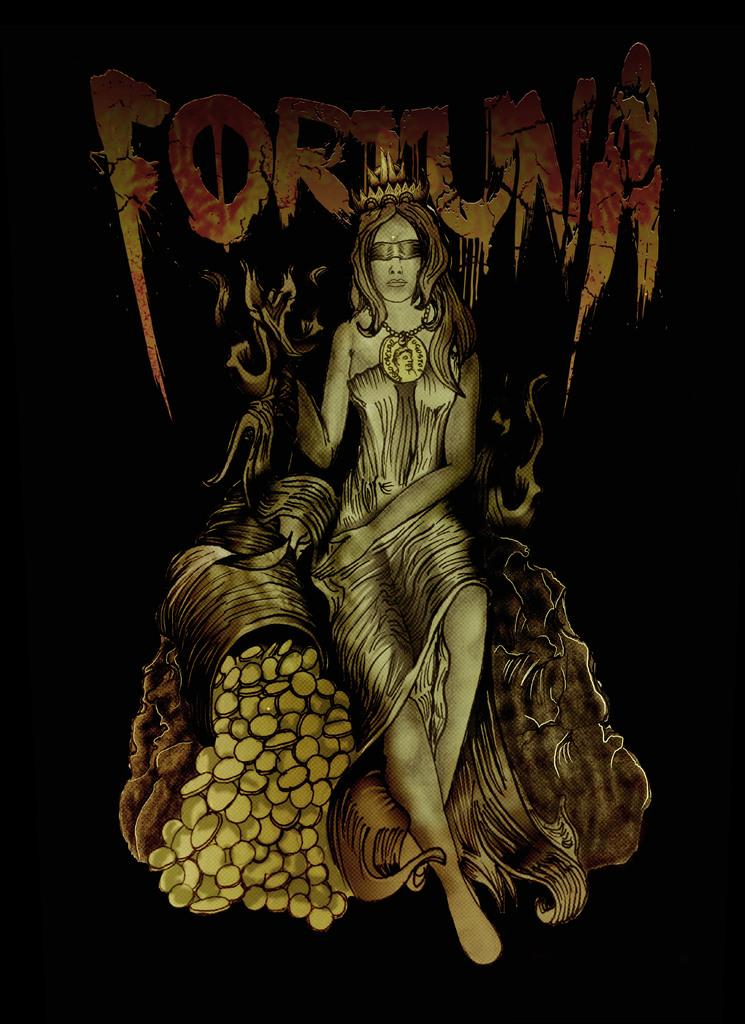What type of image is being described? The image is an illustration. Who is depicted in the illustration? There is a woman in the image. What is the woman doing in the illustration? The woman is sitting. What accessory is the woman wearing in the illustration? The woman is wearing a crown. Are there any words or letters in the illustration? Yes, there is text written on the illustration. What can be observed about the background of the image? The background of the image is dark. What type of building is on fire in the image? There is no building or fire present in the image; it is an illustration of a woman sitting with a crown and text. How does the woman's behavior change throughout the image? The image is a static illustration, so the woman's behavior does not change throughout the image. 